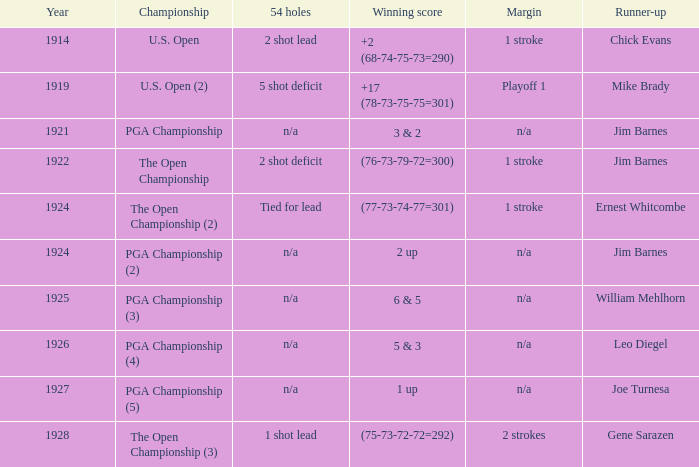WHAT WAS THE WINNING SCORE IN YEAR 1922? (76-73-79-72=300). 